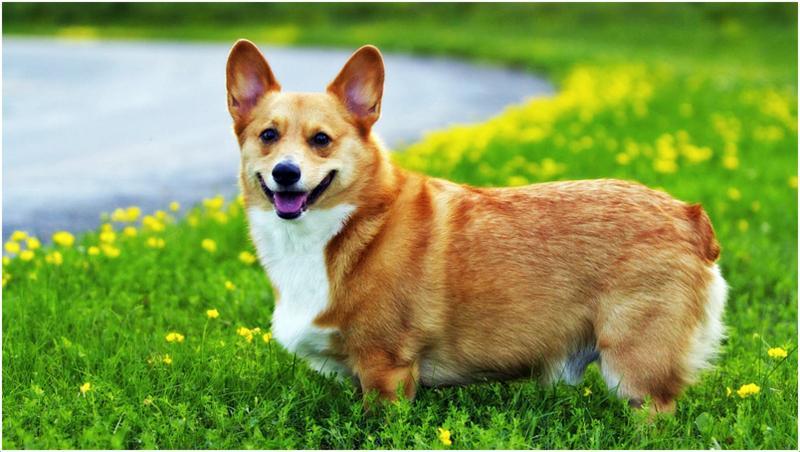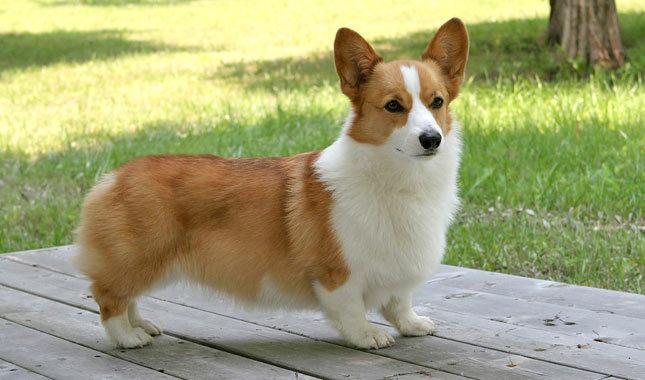The first image is the image on the left, the second image is the image on the right. Analyze the images presented: Is the assertion "The images show a total of two short-legged dogs facing in opposite directions." valid? Answer yes or no. Yes. 